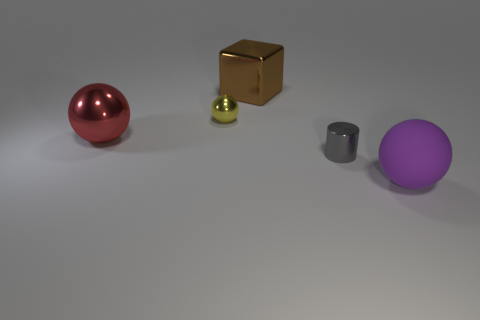Is there a cylinder of the same size as the block?
Your response must be concise. No. What number of things are large things that are in front of the red metallic thing or large matte blocks?
Offer a terse response. 1. Do the big red object and the big thing in front of the large shiny ball have the same material?
Make the answer very short. No. What number of other things are there of the same shape as the gray shiny object?
Your answer should be very brief. 0. What number of things are large balls that are to the right of the brown metal cube or shiny things left of the big brown shiny block?
Offer a terse response. 3. What number of other things are there of the same color as the shiny cube?
Ensure brevity in your answer.  0. Are there fewer tiny gray shiny things behind the big brown thing than red balls that are to the right of the metal cylinder?
Your response must be concise. No. What number of gray metallic cylinders are there?
Your answer should be compact. 1. Are there any other things that have the same material as the yellow object?
Offer a terse response. Yes. What material is the red object that is the same shape as the purple matte object?
Offer a terse response. Metal. 